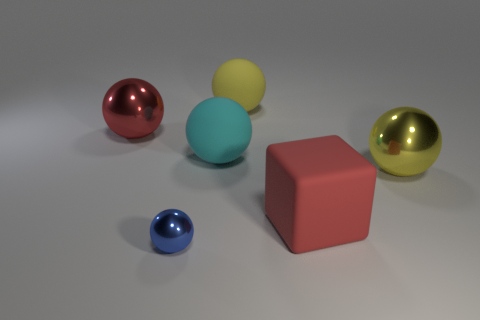Subtract 3 balls. How many balls are left? 2 Subtract all blue balls. How many balls are left? 4 Subtract all yellow shiny spheres. How many spheres are left? 4 Subtract all red balls. Subtract all yellow cylinders. How many balls are left? 4 Add 3 small purple rubber cubes. How many objects exist? 9 Subtract all balls. How many objects are left? 1 Add 3 big rubber cubes. How many big rubber cubes exist? 4 Subtract 1 red cubes. How many objects are left? 5 Subtract all tiny shiny balls. Subtract all blue metal objects. How many objects are left? 4 Add 1 cyan balls. How many cyan balls are left? 2 